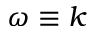Convert formula to latex. <formula><loc_0><loc_0><loc_500><loc_500>\omega \equiv k</formula> 